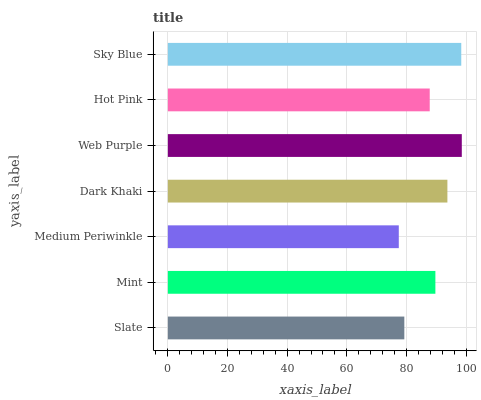Is Medium Periwinkle the minimum?
Answer yes or no. Yes. Is Web Purple the maximum?
Answer yes or no. Yes. Is Mint the minimum?
Answer yes or no. No. Is Mint the maximum?
Answer yes or no. No. Is Mint greater than Slate?
Answer yes or no. Yes. Is Slate less than Mint?
Answer yes or no. Yes. Is Slate greater than Mint?
Answer yes or no. No. Is Mint less than Slate?
Answer yes or no. No. Is Mint the high median?
Answer yes or no. Yes. Is Mint the low median?
Answer yes or no. Yes. Is Slate the high median?
Answer yes or no. No. Is Medium Periwinkle the low median?
Answer yes or no. No. 